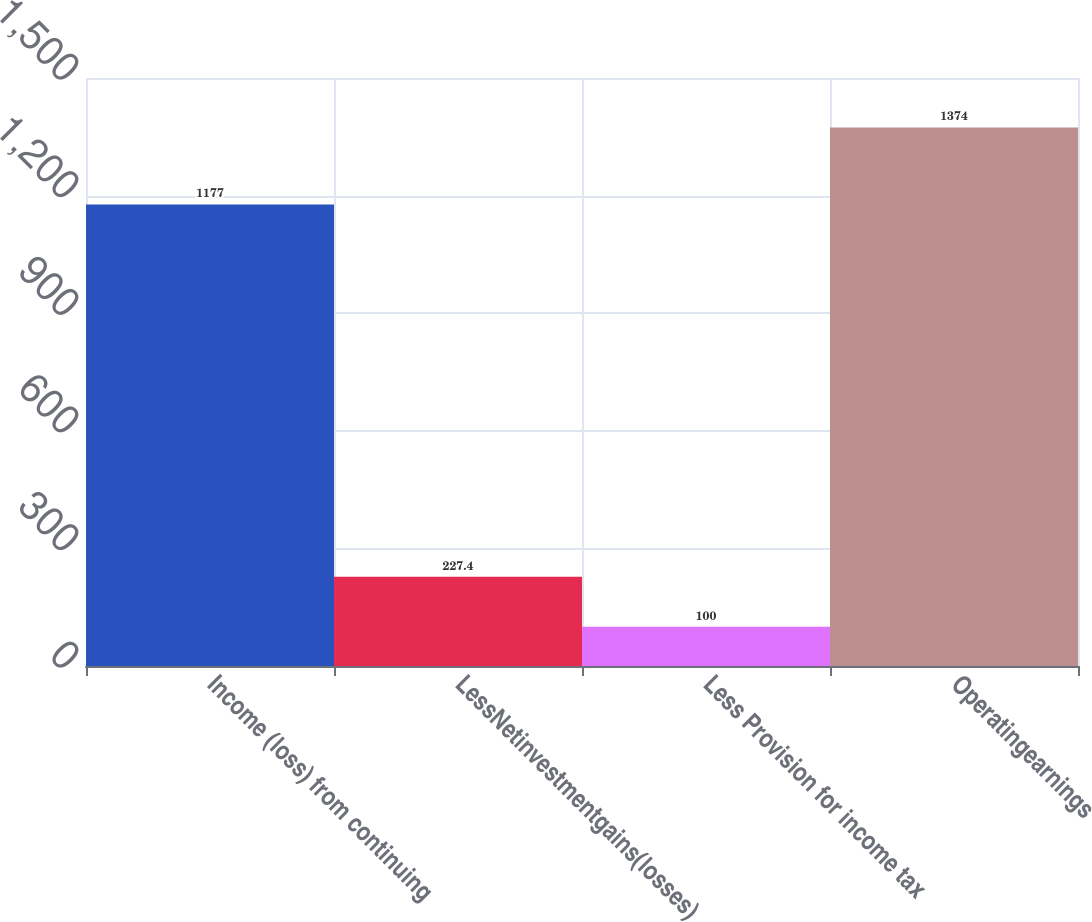<chart> <loc_0><loc_0><loc_500><loc_500><bar_chart><fcel>Income (loss) from continuing<fcel>LessNetinvestmentgains(losses)<fcel>Less Provision for income tax<fcel>Operatingearnings<nl><fcel>1177<fcel>227.4<fcel>100<fcel>1374<nl></chart> 